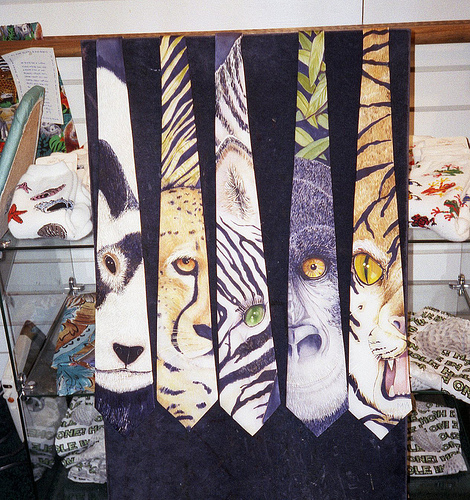Do you see both ties and glasses?
Answer the question using a single word or phrase. No Is the blanket on the left or on the right side of the picture? Left 